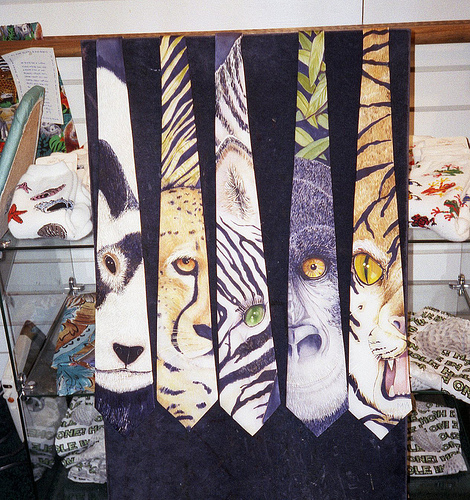Do you see both ties and glasses?
Answer the question using a single word or phrase. No Is the blanket on the left or on the right side of the picture? Left 